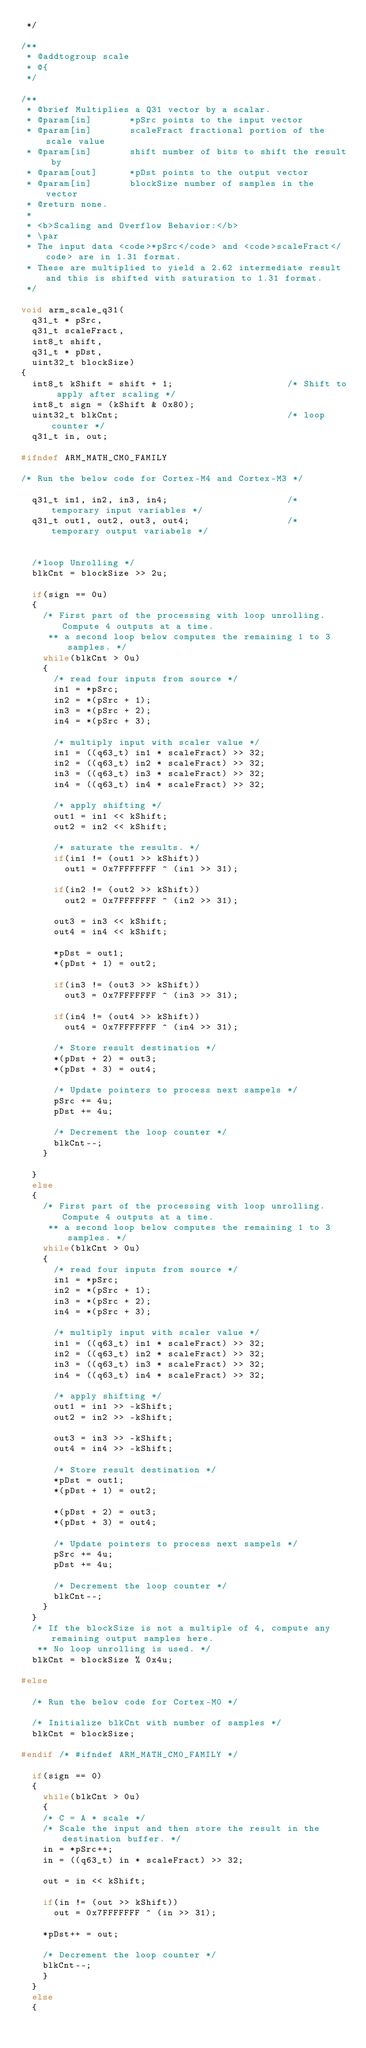<code> <loc_0><loc_0><loc_500><loc_500><_C_> */

/**       
 * @addtogroup scale       
 * @{       
 */

/**       
 * @brief Multiplies a Q31 vector by a scalar.       
 * @param[in]       *pSrc points to the input vector       
 * @param[in]       scaleFract fractional portion of the scale value       
 * @param[in]       shift number of bits to shift the result by       
 * @param[out]      *pDst points to the output vector       
 * @param[in]       blockSize number of samples in the vector       
 * @return none.       
 *       
 * <b>Scaling and Overflow Behavior:</b>       
 * \par       
 * The input data <code>*pSrc</code> and <code>scaleFract</code> are in 1.31 format.       
 * These are multiplied to yield a 2.62 intermediate result and this is shifted with saturation to 1.31 format.       
 */

void arm_scale_q31(
  q31_t * pSrc,
  q31_t scaleFract,
  int8_t shift,
  q31_t * pDst,
  uint32_t blockSize)
{
  int8_t kShift = shift + 1;                     /* Shift to apply after scaling */
  int8_t sign = (kShift & 0x80);
  uint32_t blkCnt;                               /* loop counter */
  q31_t in, out;

#ifndef ARM_MATH_CM0_FAMILY

/* Run the below code for Cortex-M4 and Cortex-M3 */

  q31_t in1, in2, in3, in4;                      /* temporary input variables */
  q31_t out1, out2, out3, out4;                  /* temporary output variabels */


  /*loop Unrolling */
  blkCnt = blockSize >> 2u;

  if(sign == 0u)
  {
    /* First part of the processing with loop unrolling.  Compute 4 outputs at a time.       
     ** a second loop below computes the remaining 1 to 3 samples. */
    while(blkCnt > 0u)
    {
      /* read four inputs from source */
      in1 = *pSrc;
      in2 = *(pSrc + 1);
      in3 = *(pSrc + 2);
      in4 = *(pSrc + 3);

      /* multiply input with scaler value */
      in1 = ((q63_t) in1 * scaleFract) >> 32;
      in2 = ((q63_t) in2 * scaleFract) >> 32;
      in3 = ((q63_t) in3 * scaleFract) >> 32;
      in4 = ((q63_t) in4 * scaleFract) >> 32;

      /* apply shifting */
      out1 = in1 << kShift;
      out2 = in2 << kShift;

      /* saturate the results. */
      if(in1 != (out1 >> kShift))
        out1 = 0x7FFFFFFF ^ (in1 >> 31);

      if(in2 != (out2 >> kShift))
        out2 = 0x7FFFFFFF ^ (in2 >> 31);

      out3 = in3 << kShift;
      out4 = in4 << kShift;

      *pDst = out1;
      *(pDst + 1) = out2;

      if(in3 != (out3 >> kShift))
        out3 = 0x7FFFFFFF ^ (in3 >> 31);

      if(in4 != (out4 >> kShift))
        out4 = 0x7FFFFFFF ^ (in4 >> 31);

      /* Store result destination */
      *(pDst + 2) = out3;
      *(pDst + 3) = out4;

      /* Update pointers to process next sampels */
      pSrc += 4u;
      pDst += 4u;

      /* Decrement the loop counter */
      blkCnt--;
    }

  }
  else
  {
    /* First part of the processing with loop unrolling.  Compute 4 outputs at a time.       
     ** a second loop below computes the remaining 1 to 3 samples. */
    while(blkCnt > 0u)
    {
      /* read four inputs from source */
      in1 = *pSrc;
      in2 = *(pSrc + 1);
      in3 = *(pSrc + 2);
      in4 = *(pSrc + 3);

      /* multiply input with scaler value */
      in1 = ((q63_t) in1 * scaleFract) >> 32;
      in2 = ((q63_t) in2 * scaleFract) >> 32;
      in3 = ((q63_t) in3 * scaleFract) >> 32;
      in4 = ((q63_t) in4 * scaleFract) >> 32;

      /* apply shifting */
      out1 = in1 >> -kShift;
      out2 = in2 >> -kShift;

      out3 = in3 >> -kShift;
      out4 = in4 >> -kShift;

      /* Store result destination */
      *pDst = out1;
      *(pDst + 1) = out2;

      *(pDst + 2) = out3;
      *(pDst + 3) = out4;

      /* Update pointers to process next sampels */
      pSrc += 4u;
      pDst += 4u;

      /* Decrement the loop counter */
      blkCnt--;
    }
  }
  /* If the blockSize is not a multiple of 4, compute any remaining output samples here.       
   ** No loop unrolling is used. */
  blkCnt = blockSize % 0x4u;

#else

  /* Run the below code for Cortex-M0 */

  /* Initialize blkCnt with number of samples */
  blkCnt = blockSize;

#endif /* #ifndef ARM_MATH_CM0_FAMILY */

  if(sign == 0)
  {
	  while(blkCnt > 0u)
	  {
		/* C = A * scale */
		/* Scale the input and then store the result in the destination buffer. */
		in = *pSrc++;
		in = ((q63_t) in * scaleFract) >> 32;

		out = in << kShift;
		
		if(in != (out >> kShift))
			out = 0x7FFFFFFF ^ (in >> 31);

		*pDst++ = out;

		/* Decrement the loop counter */
		blkCnt--;
	  }
  }
  else
  {</code> 